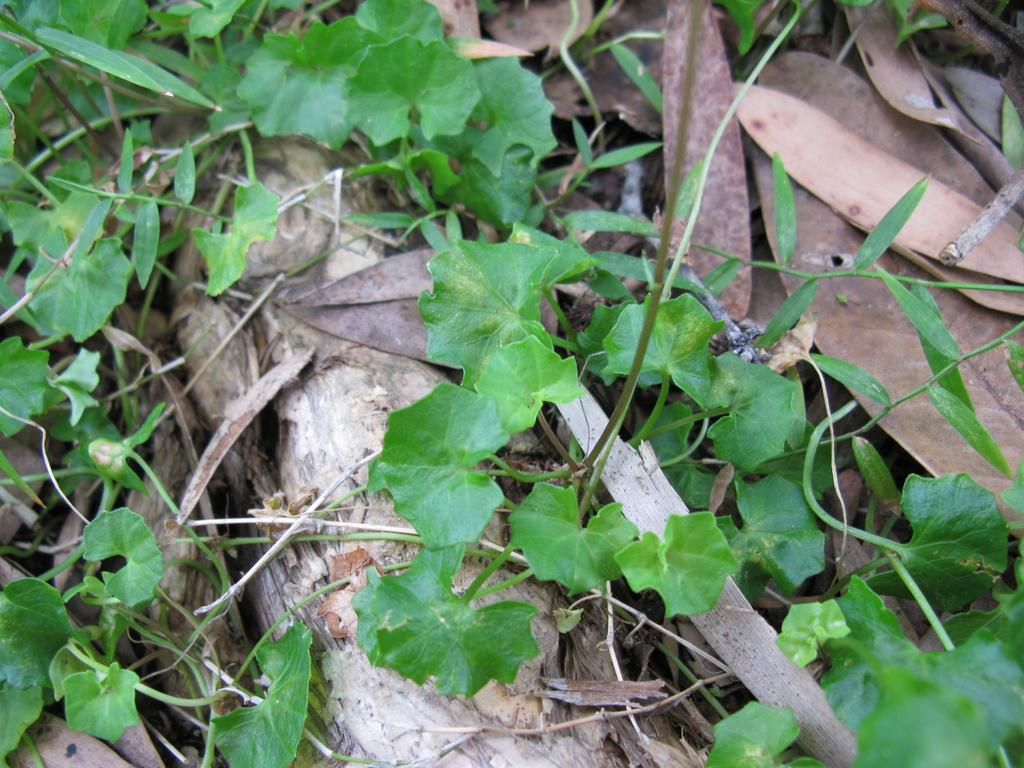What type of living organisms can be seen in the image? Plants can be seen in the image. What material is present in the image? Wood is present in the image. What is the condition of the leaves on the plants in the image? Dried leaves are present in the image. What type of produce can be seen hanging from the plants in the image? There is no produce visible in the image. 